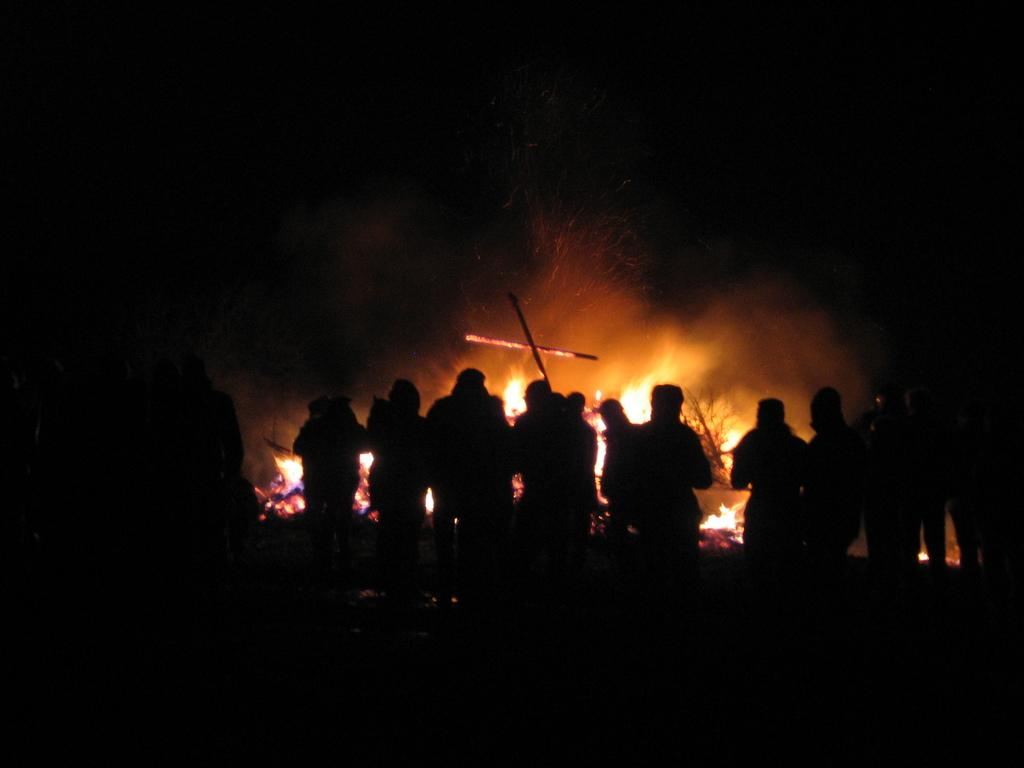How many people are in the image? There is a group of people in the image. What are the people doing in the image? The people are standing in the image. What can be seen behind the people in the image? There is a fire behind the people in the image. What is the color of the background in the image? The background of the image is dark. What type of pet can be seen participating in the feast in the image? There is no feast or pet present in the image. What type of wilderness can be seen in the background of the image? There is no wilderness visible in the background of the image; it is dark. 